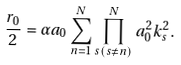Convert formula to latex. <formula><loc_0><loc_0><loc_500><loc_500>\frac { r _ { 0 } } { 2 } = \alpha a _ { 0 } \sum _ { n = 1 } ^ { N } \prod _ { s ( s \neq n ) } ^ { N } a _ { 0 } ^ { 2 } k _ { s } ^ { 2 } .</formula> 